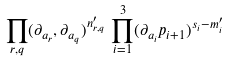Convert formula to latex. <formula><loc_0><loc_0><loc_500><loc_500>\prod _ { r , q } ( \partial _ { a _ { r } } , \partial _ { a _ { q } } ) ^ { n _ { r , q } ^ { \prime } } \, \prod _ { i = 1 } ^ { 3 } ( \partial _ { a _ { i } } p _ { i + 1 } ) ^ { s _ { i } - m _ { i } ^ { \prime } }</formula> 